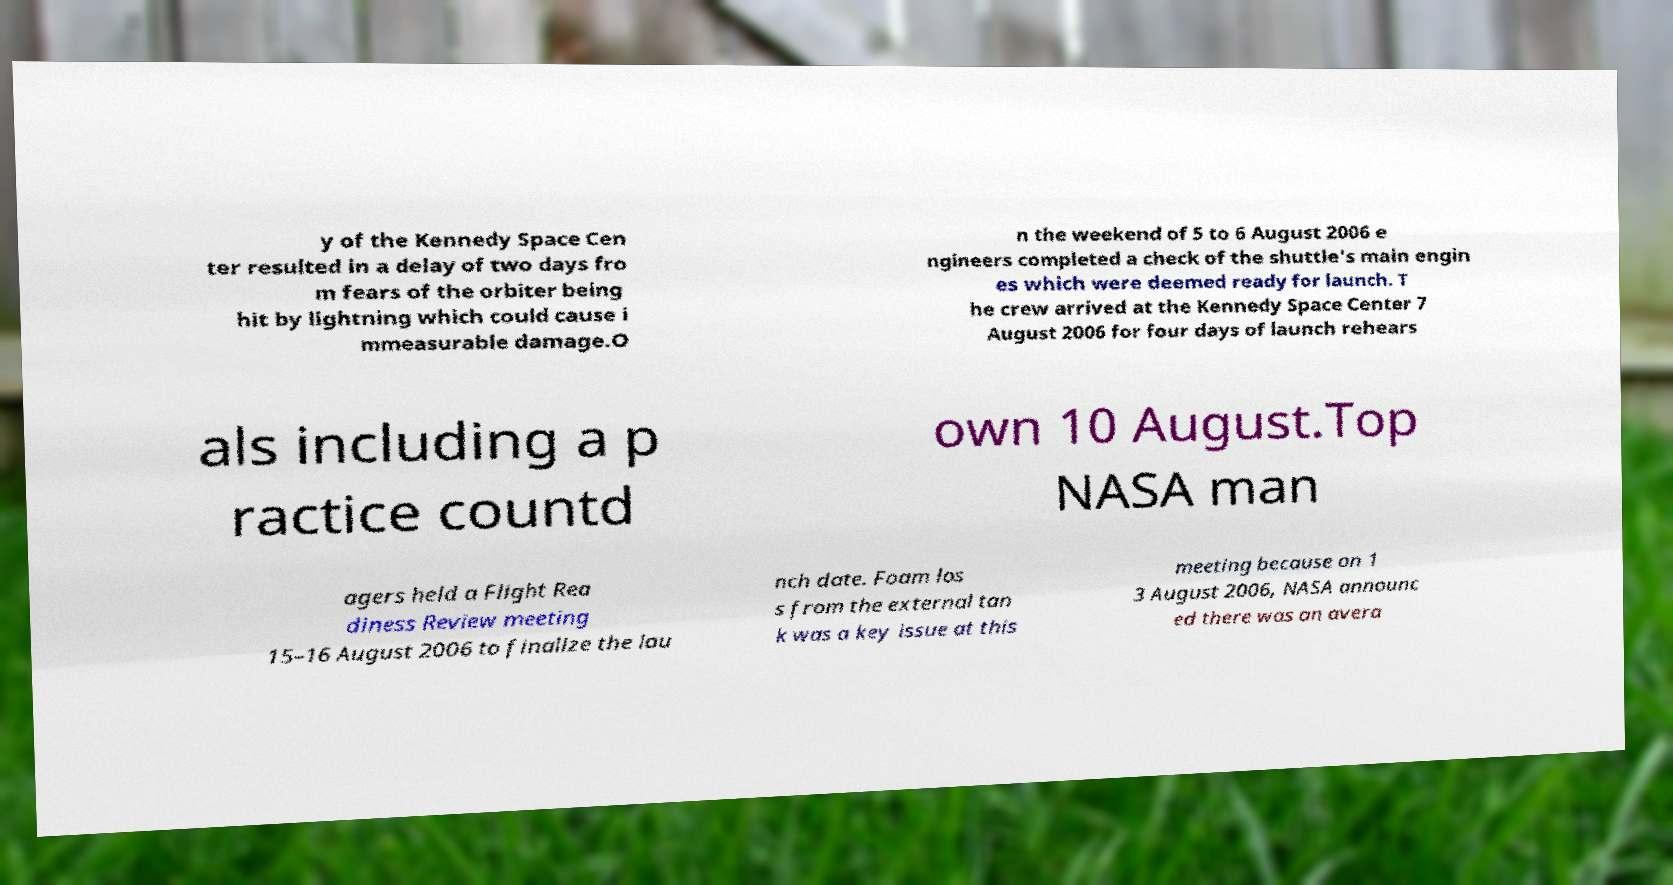Could you assist in decoding the text presented in this image and type it out clearly? y of the Kennedy Space Cen ter resulted in a delay of two days fro m fears of the orbiter being hit by lightning which could cause i mmeasurable damage.O n the weekend of 5 to 6 August 2006 e ngineers completed a check of the shuttle's main engin es which were deemed ready for launch. T he crew arrived at the Kennedy Space Center 7 August 2006 for four days of launch rehears als including a p ractice countd own 10 August.Top NASA man agers held a Flight Rea diness Review meeting 15–16 August 2006 to finalize the lau nch date. Foam los s from the external tan k was a key issue at this meeting because on 1 3 August 2006, NASA announc ed there was an avera 